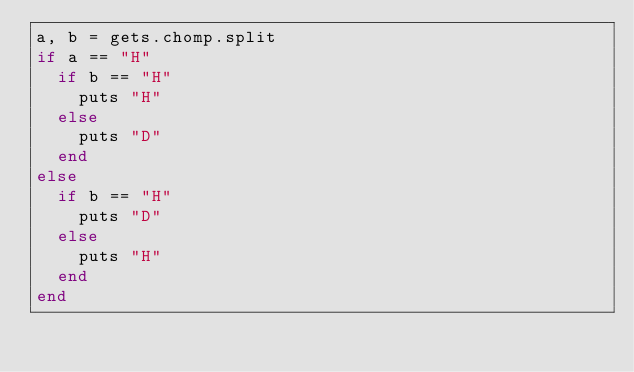Convert code to text. <code><loc_0><loc_0><loc_500><loc_500><_Ruby_>a, b = gets.chomp.split
if a == "H"
  if b == "H"
    puts "H"
  else
    puts "D"
  end
else
  if b == "H"
    puts "D"
  else
    puts "H"
  end
end
</code> 